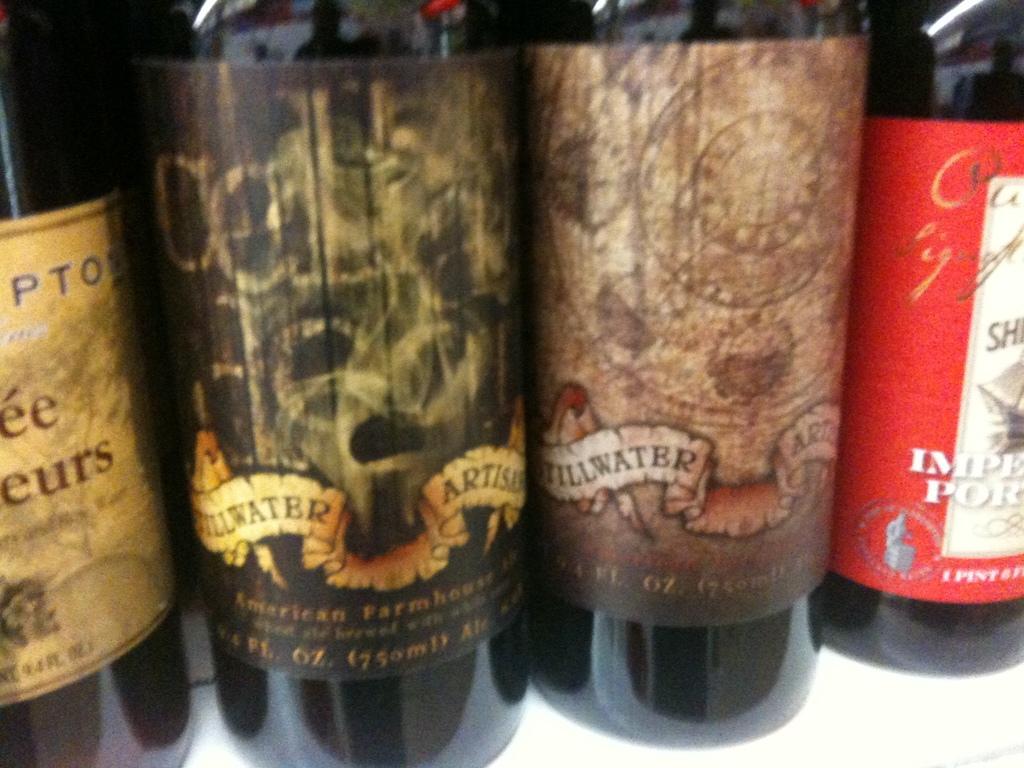How many pints in the red labeled bottle?
Provide a short and direct response. 1. 